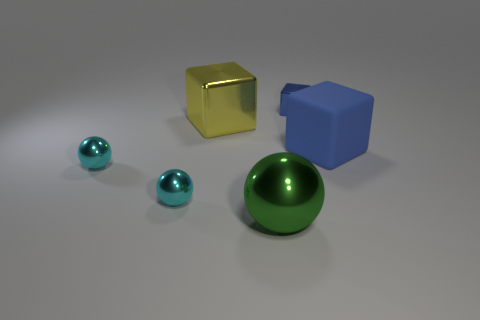There is a large ball in front of the blue cube that is to the left of the rubber thing; what is its color?
Make the answer very short. Green. There is a object right of the cube behind the big metallic block; how big is it?
Keep it short and to the point. Large. The other block that is the same color as the small cube is what size?
Your answer should be compact. Large. How many other things are the same size as the green ball?
Provide a short and direct response. 2. There is a big object behind the blue thing in front of the blue object behind the blue rubber object; what color is it?
Your answer should be compact. Yellow. How many other things are the same shape as the green object?
Your response must be concise. 2. What shape is the metallic object to the right of the big metallic ball?
Your answer should be compact. Cube. Are there any large yellow metallic cubes that are on the right side of the small thing that is behind the blue matte object?
Your answer should be compact. No. The big thing that is behind the green metallic sphere and to the left of the tiny blue metal thing is what color?
Your answer should be compact. Yellow. There is a big thing that is on the right side of the blue block that is behind the blue matte cube; is there a blue rubber cube that is left of it?
Your answer should be very brief. No. 